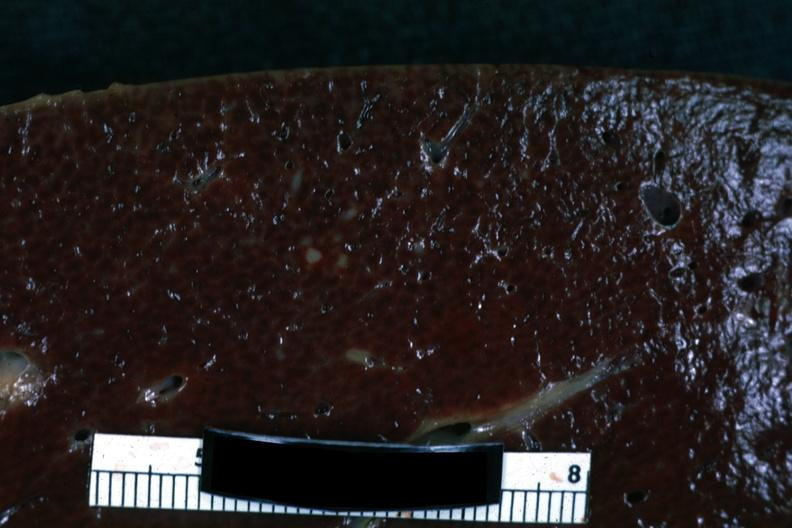what does this image show?
Answer the question using a single word or phrase. Cut surface with focal infiltrate 